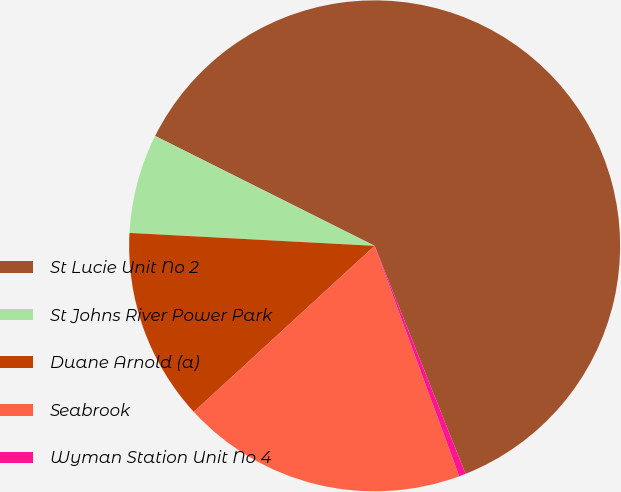Convert chart to OTSL. <chart><loc_0><loc_0><loc_500><loc_500><pie_chart><fcel>St Lucie Unit No 2<fcel>St Johns River Power Park<fcel>Duane Arnold (a)<fcel>Seabrook<fcel>Wyman Station Unit No 4<nl><fcel>61.57%<fcel>6.55%<fcel>12.66%<fcel>18.78%<fcel>0.44%<nl></chart> 